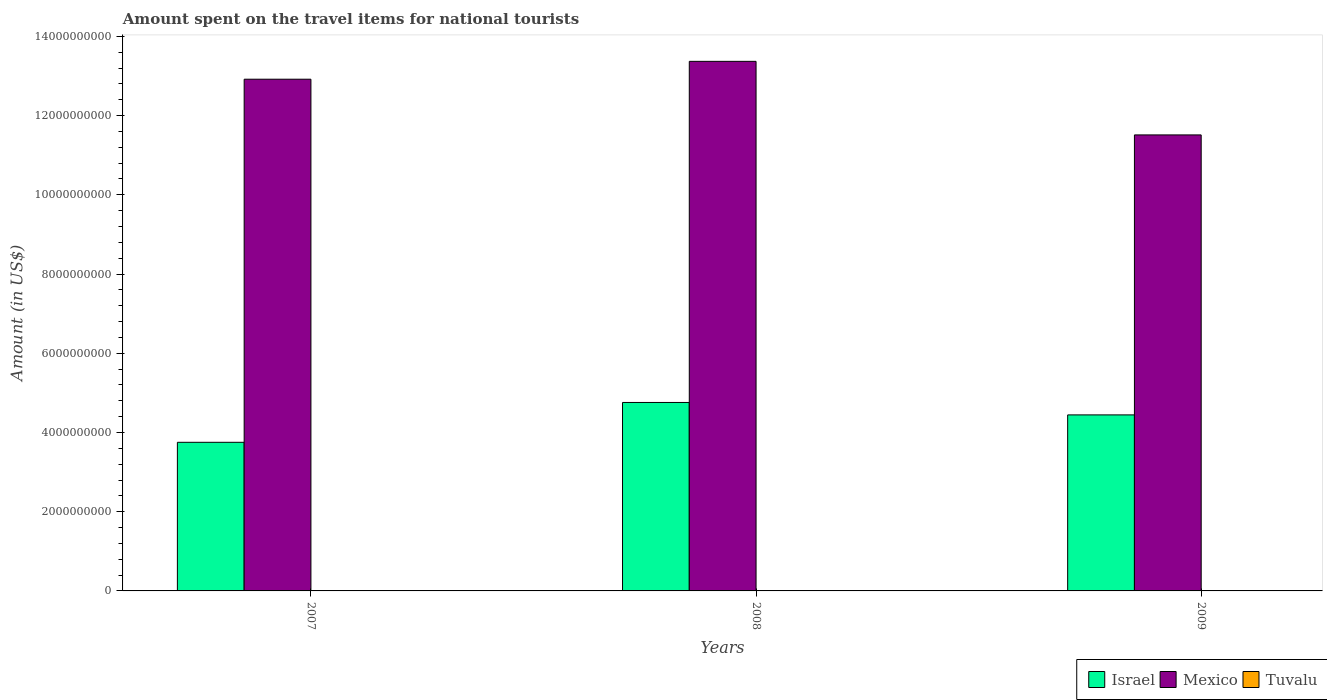Are the number of bars on each tick of the X-axis equal?
Your response must be concise. Yes. How many bars are there on the 3rd tick from the left?
Your response must be concise. 3. What is the label of the 1st group of bars from the left?
Offer a very short reply. 2007. In how many cases, is the number of bars for a given year not equal to the number of legend labels?
Ensure brevity in your answer.  0. What is the amount spent on the travel items for national tourists in Israel in 2009?
Ensure brevity in your answer.  4.44e+09. Across all years, what is the maximum amount spent on the travel items for national tourists in Tuvalu?
Your response must be concise. 1.87e+06. Across all years, what is the minimum amount spent on the travel items for national tourists in Israel?
Ensure brevity in your answer.  3.75e+09. In which year was the amount spent on the travel items for national tourists in Israel maximum?
Your answer should be compact. 2008. In which year was the amount spent on the travel items for national tourists in Mexico minimum?
Provide a short and direct response. 2009. What is the total amount spent on the travel items for national tourists in Tuvalu in the graph?
Your answer should be compact. 4.91e+06. What is the difference between the amount spent on the travel items for national tourists in Mexico in 2008 and the amount spent on the travel items for national tourists in Israel in 2007?
Offer a terse response. 9.62e+09. What is the average amount spent on the travel items for national tourists in Mexico per year?
Make the answer very short. 1.26e+1. In the year 2007, what is the difference between the amount spent on the travel items for national tourists in Mexico and amount spent on the travel items for national tourists in Israel?
Give a very brief answer. 9.17e+09. What is the ratio of the amount spent on the travel items for national tourists in Mexico in 2007 to that in 2008?
Your response must be concise. 0.97. Is the amount spent on the travel items for national tourists in Tuvalu in 2007 less than that in 2008?
Offer a terse response. Yes. Is the difference between the amount spent on the travel items for national tourists in Mexico in 2007 and 2009 greater than the difference between the amount spent on the travel items for national tourists in Israel in 2007 and 2009?
Keep it short and to the point. Yes. What is the difference between the highest and the second highest amount spent on the travel items for national tourists in Israel?
Your response must be concise. 3.14e+08. What is the difference between the highest and the lowest amount spent on the travel items for national tourists in Tuvalu?
Your response must be concise. 3.60e+05. In how many years, is the amount spent on the travel items for national tourists in Tuvalu greater than the average amount spent on the travel items for national tourists in Tuvalu taken over all years?
Your answer should be very brief. 1. Is the sum of the amount spent on the travel items for national tourists in Israel in 2007 and 2008 greater than the maximum amount spent on the travel items for national tourists in Tuvalu across all years?
Your answer should be compact. Yes. What does the 2nd bar from the right in 2007 represents?
Make the answer very short. Mexico. How many bars are there?
Your response must be concise. 9. How many years are there in the graph?
Ensure brevity in your answer.  3. Are the values on the major ticks of Y-axis written in scientific E-notation?
Your answer should be very brief. No. Does the graph contain any zero values?
Provide a succinct answer. No. Does the graph contain grids?
Offer a terse response. No. How many legend labels are there?
Provide a short and direct response. 3. How are the legend labels stacked?
Keep it short and to the point. Horizontal. What is the title of the graph?
Your response must be concise. Amount spent on the travel items for national tourists. Does "Tajikistan" appear as one of the legend labels in the graph?
Offer a very short reply. No. What is the label or title of the X-axis?
Provide a succinct answer. Years. What is the label or title of the Y-axis?
Your answer should be compact. Amount (in US$). What is the Amount (in US$) in Israel in 2007?
Ensure brevity in your answer.  3.75e+09. What is the Amount (in US$) of Mexico in 2007?
Give a very brief answer. 1.29e+1. What is the Amount (in US$) of Tuvalu in 2007?
Give a very brief answer. 1.51e+06. What is the Amount (in US$) of Israel in 2008?
Ensure brevity in your answer.  4.76e+09. What is the Amount (in US$) in Mexico in 2008?
Offer a terse response. 1.34e+1. What is the Amount (in US$) in Tuvalu in 2008?
Give a very brief answer. 1.87e+06. What is the Amount (in US$) of Israel in 2009?
Make the answer very short. 4.44e+09. What is the Amount (in US$) of Mexico in 2009?
Offer a terse response. 1.15e+1. What is the Amount (in US$) of Tuvalu in 2009?
Ensure brevity in your answer.  1.53e+06. Across all years, what is the maximum Amount (in US$) of Israel?
Your answer should be compact. 4.76e+09. Across all years, what is the maximum Amount (in US$) in Mexico?
Offer a terse response. 1.34e+1. Across all years, what is the maximum Amount (in US$) in Tuvalu?
Keep it short and to the point. 1.87e+06. Across all years, what is the minimum Amount (in US$) in Israel?
Your response must be concise. 3.75e+09. Across all years, what is the minimum Amount (in US$) in Mexico?
Offer a terse response. 1.15e+1. Across all years, what is the minimum Amount (in US$) of Tuvalu?
Make the answer very short. 1.51e+06. What is the total Amount (in US$) in Israel in the graph?
Give a very brief answer. 1.30e+1. What is the total Amount (in US$) in Mexico in the graph?
Ensure brevity in your answer.  3.78e+1. What is the total Amount (in US$) of Tuvalu in the graph?
Ensure brevity in your answer.  4.91e+06. What is the difference between the Amount (in US$) in Israel in 2007 and that in 2008?
Your answer should be compact. -1.01e+09. What is the difference between the Amount (in US$) in Mexico in 2007 and that in 2008?
Your answer should be compact. -4.51e+08. What is the difference between the Amount (in US$) of Tuvalu in 2007 and that in 2008?
Give a very brief answer. -3.60e+05. What is the difference between the Amount (in US$) in Israel in 2007 and that in 2009?
Ensure brevity in your answer.  -6.92e+08. What is the difference between the Amount (in US$) in Mexico in 2007 and that in 2009?
Give a very brief answer. 1.41e+09. What is the difference between the Amount (in US$) of Tuvalu in 2007 and that in 2009?
Keep it short and to the point. -2.00e+04. What is the difference between the Amount (in US$) in Israel in 2008 and that in 2009?
Offer a terse response. 3.14e+08. What is the difference between the Amount (in US$) in Mexico in 2008 and that in 2009?
Provide a short and direct response. 1.86e+09. What is the difference between the Amount (in US$) in Tuvalu in 2008 and that in 2009?
Offer a very short reply. 3.40e+05. What is the difference between the Amount (in US$) of Israel in 2007 and the Amount (in US$) of Mexico in 2008?
Provide a succinct answer. -9.62e+09. What is the difference between the Amount (in US$) in Israel in 2007 and the Amount (in US$) in Tuvalu in 2008?
Give a very brief answer. 3.75e+09. What is the difference between the Amount (in US$) of Mexico in 2007 and the Amount (in US$) of Tuvalu in 2008?
Provide a succinct answer. 1.29e+1. What is the difference between the Amount (in US$) in Israel in 2007 and the Amount (in US$) in Mexico in 2009?
Make the answer very short. -7.76e+09. What is the difference between the Amount (in US$) in Israel in 2007 and the Amount (in US$) in Tuvalu in 2009?
Provide a succinct answer. 3.75e+09. What is the difference between the Amount (in US$) of Mexico in 2007 and the Amount (in US$) of Tuvalu in 2009?
Your answer should be compact. 1.29e+1. What is the difference between the Amount (in US$) of Israel in 2008 and the Amount (in US$) of Mexico in 2009?
Make the answer very short. -6.76e+09. What is the difference between the Amount (in US$) of Israel in 2008 and the Amount (in US$) of Tuvalu in 2009?
Offer a terse response. 4.76e+09. What is the difference between the Amount (in US$) in Mexico in 2008 and the Amount (in US$) in Tuvalu in 2009?
Offer a very short reply. 1.34e+1. What is the average Amount (in US$) of Israel per year?
Make the answer very short. 4.32e+09. What is the average Amount (in US$) in Mexico per year?
Offer a very short reply. 1.26e+1. What is the average Amount (in US$) in Tuvalu per year?
Keep it short and to the point. 1.64e+06. In the year 2007, what is the difference between the Amount (in US$) in Israel and Amount (in US$) in Mexico?
Ensure brevity in your answer.  -9.17e+09. In the year 2007, what is the difference between the Amount (in US$) in Israel and Amount (in US$) in Tuvalu?
Give a very brief answer. 3.75e+09. In the year 2007, what is the difference between the Amount (in US$) of Mexico and Amount (in US$) of Tuvalu?
Your answer should be very brief. 1.29e+1. In the year 2008, what is the difference between the Amount (in US$) of Israel and Amount (in US$) of Mexico?
Provide a short and direct response. -8.61e+09. In the year 2008, what is the difference between the Amount (in US$) in Israel and Amount (in US$) in Tuvalu?
Provide a succinct answer. 4.76e+09. In the year 2008, what is the difference between the Amount (in US$) in Mexico and Amount (in US$) in Tuvalu?
Ensure brevity in your answer.  1.34e+1. In the year 2009, what is the difference between the Amount (in US$) of Israel and Amount (in US$) of Mexico?
Your answer should be very brief. -7.07e+09. In the year 2009, what is the difference between the Amount (in US$) in Israel and Amount (in US$) in Tuvalu?
Ensure brevity in your answer.  4.44e+09. In the year 2009, what is the difference between the Amount (in US$) in Mexico and Amount (in US$) in Tuvalu?
Offer a very short reply. 1.15e+1. What is the ratio of the Amount (in US$) of Israel in 2007 to that in 2008?
Keep it short and to the point. 0.79. What is the ratio of the Amount (in US$) of Mexico in 2007 to that in 2008?
Offer a terse response. 0.97. What is the ratio of the Amount (in US$) of Tuvalu in 2007 to that in 2008?
Your answer should be very brief. 0.81. What is the ratio of the Amount (in US$) in Israel in 2007 to that in 2009?
Provide a succinct answer. 0.84. What is the ratio of the Amount (in US$) in Mexico in 2007 to that in 2009?
Ensure brevity in your answer.  1.12. What is the ratio of the Amount (in US$) in Tuvalu in 2007 to that in 2009?
Keep it short and to the point. 0.99. What is the ratio of the Amount (in US$) in Israel in 2008 to that in 2009?
Offer a very short reply. 1.07. What is the ratio of the Amount (in US$) of Mexico in 2008 to that in 2009?
Keep it short and to the point. 1.16. What is the ratio of the Amount (in US$) of Tuvalu in 2008 to that in 2009?
Give a very brief answer. 1.22. What is the difference between the highest and the second highest Amount (in US$) of Israel?
Your answer should be very brief. 3.14e+08. What is the difference between the highest and the second highest Amount (in US$) of Mexico?
Offer a very short reply. 4.51e+08. What is the difference between the highest and the second highest Amount (in US$) of Tuvalu?
Offer a terse response. 3.40e+05. What is the difference between the highest and the lowest Amount (in US$) of Israel?
Your response must be concise. 1.01e+09. What is the difference between the highest and the lowest Amount (in US$) of Mexico?
Give a very brief answer. 1.86e+09. What is the difference between the highest and the lowest Amount (in US$) of Tuvalu?
Offer a very short reply. 3.60e+05. 